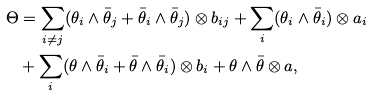Convert formula to latex. <formula><loc_0><loc_0><loc_500><loc_500>\Theta & = \sum _ { i \neq j } ( \theta _ { i } \wedge \bar { \theta } _ { j } + \bar { \theta } _ { i } \wedge \bar { \theta } _ { j } ) \otimes b _ { i j } + \sum _ { i } ( \theta _ { i } \wedge \bar { \theta } _ { i } ) \otimes a _ { i } \\ & + \sum _ { i } ( \theta \wedge \bar { \theta } _ { i } + \bar { \theta } \wedge \bar { \theta } _ { i } ) \otimes b _ { i } + \theta \wedge \bar { \theta } \otimes a ,</formula> 